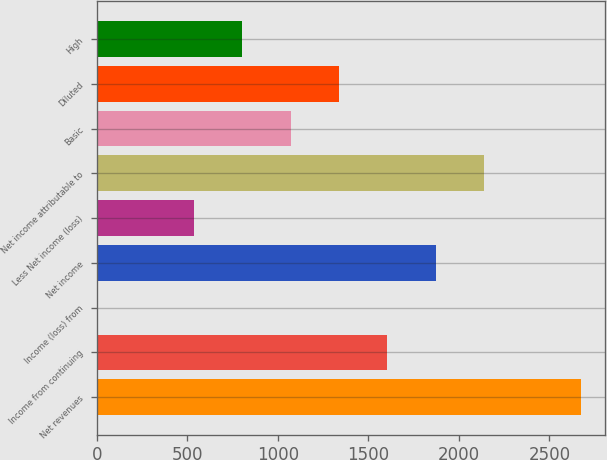Convert chart to OTSL. <chart><loc_0><loc_0><loc_500><loc_500><bar_chart><fcel>Net revenues<fcel>Income from continuing<fcel>Income (loss) from<fcel>Net income<fcel>Less Net income (loss)<fcel>Net income attributable to<fcel>Basic<fcel>Diluted<fcel>High<nl><fcel>2674<fcel>1604.8<fcel>1<fcel>1872.1<fcel>535.6<fcel>2139.4<fcel>1070.2<fcel>1337.5<fcel>802.9<nl></chart> 